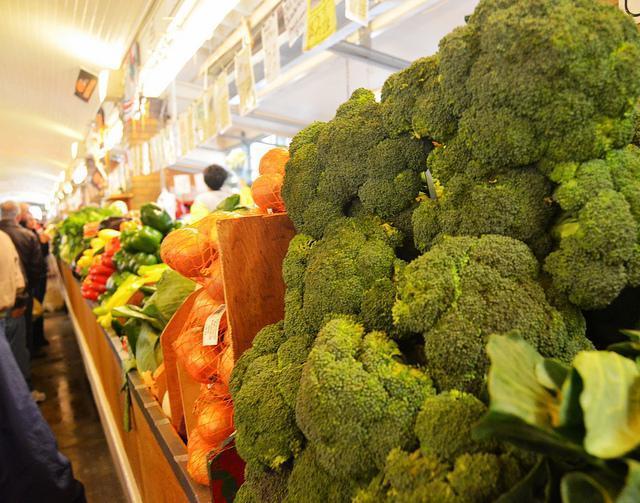How many people are in the photo?
Give a very brief answer. 3. 